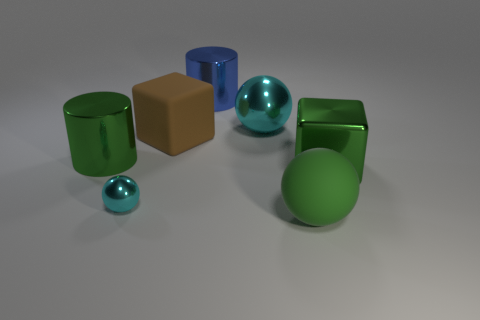What kind of setting or environment does the lighting in the image suggest? The diffuse lighting and neutral background suggest an indoor environment, possibly a photographer's studio or a space designed for product display with controlled lighting conditions. 